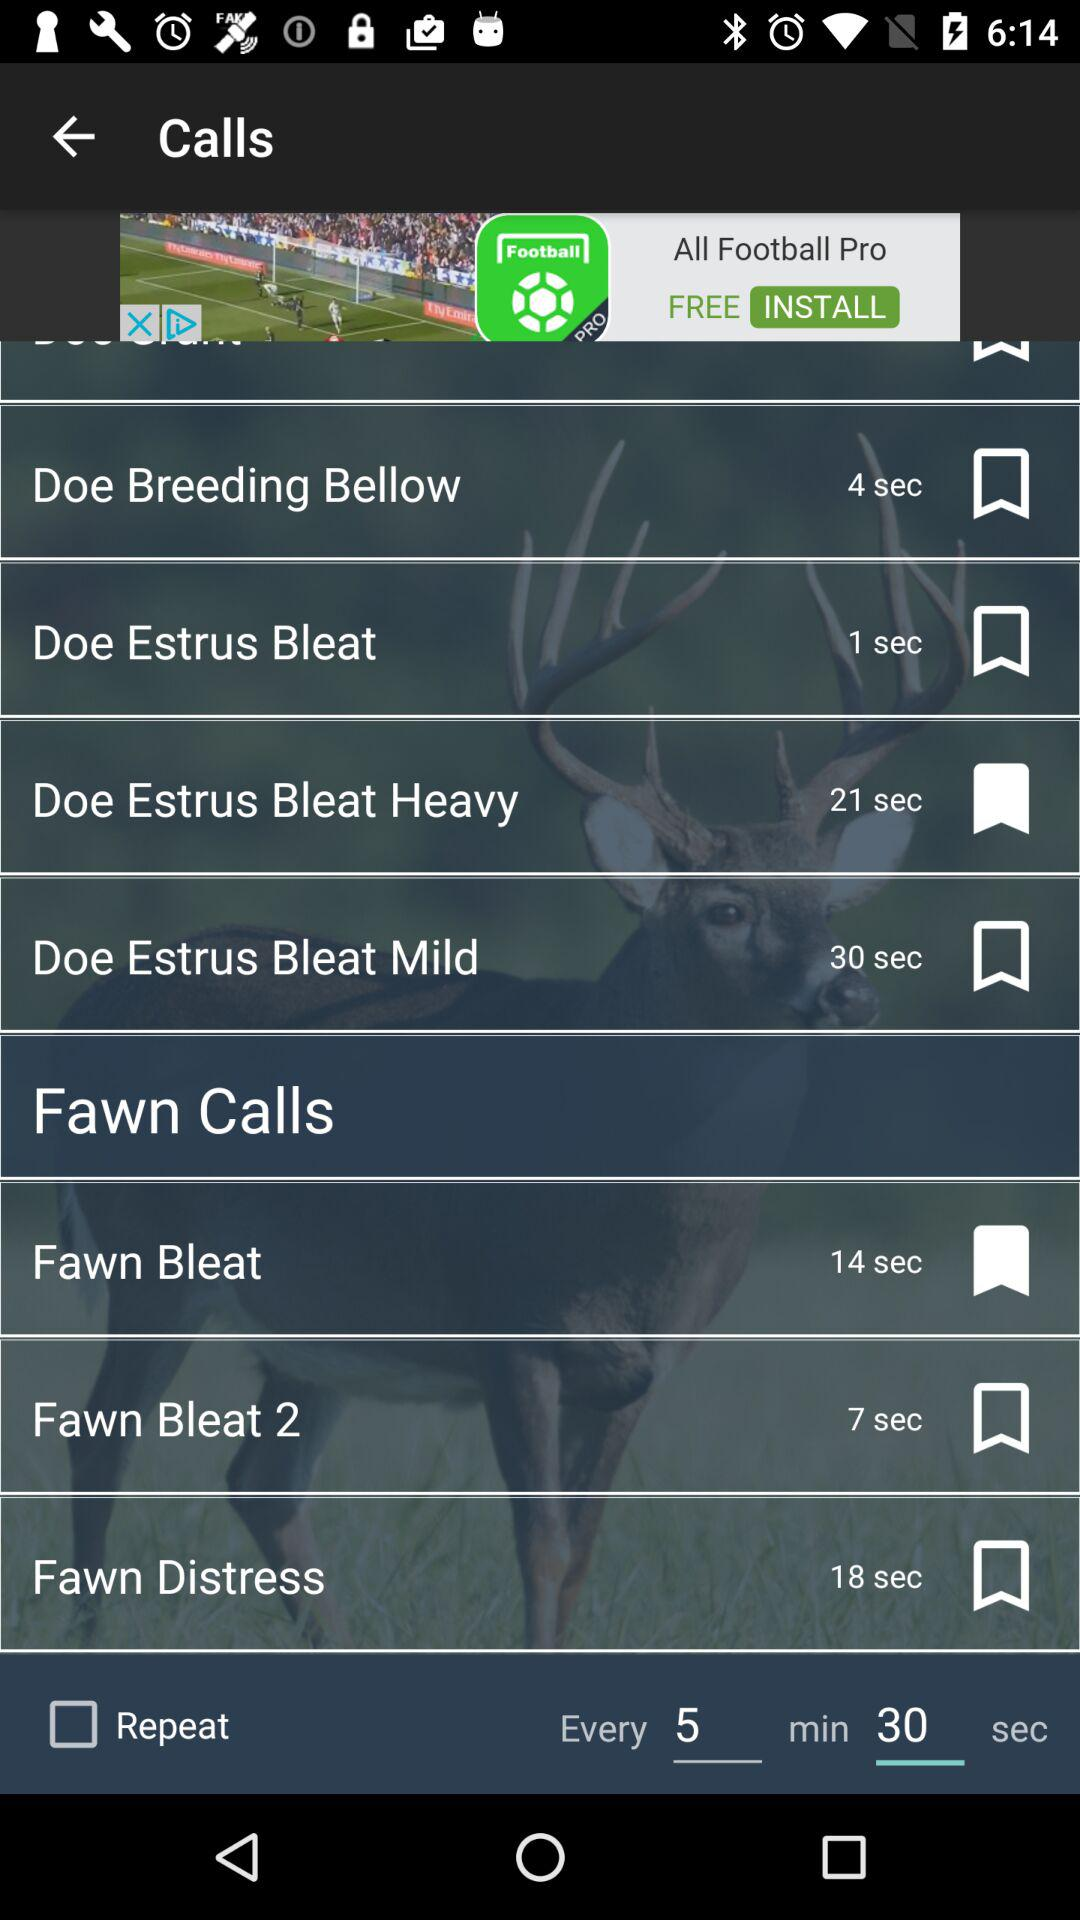What is the selected time for the "Repeat" option? The selected time for the "Repeat" option is 5 minutes and 30 seconds. 